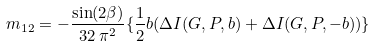<formula> <loc_0><loc_0><loc_500><loc_500>m _ { 1 2 } = - \frac { \sin ( 2 \beta ) } { 3 2 \, \pi ^ { 2 } } \{ \frac { 1 } { 2 } b ( \Delta I ( G , P , b ) + \Delta I ( G , P , - b ) ) \}</formula> 